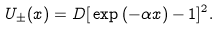<formula> <loc_0><loc_0><loc_500><loc_500>U _ { \pm } ( x ) = D [ \, \exp { ( - \alpha x ) } - 1 ] ^ { 2 } .</formula> 